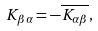Convert formula to latex. <formula><loc_0><loc_0><loc_500><loc_500>K _ { \beta \alpha } = - \overline { K _ { \alpha \beta } } ,</formula> 